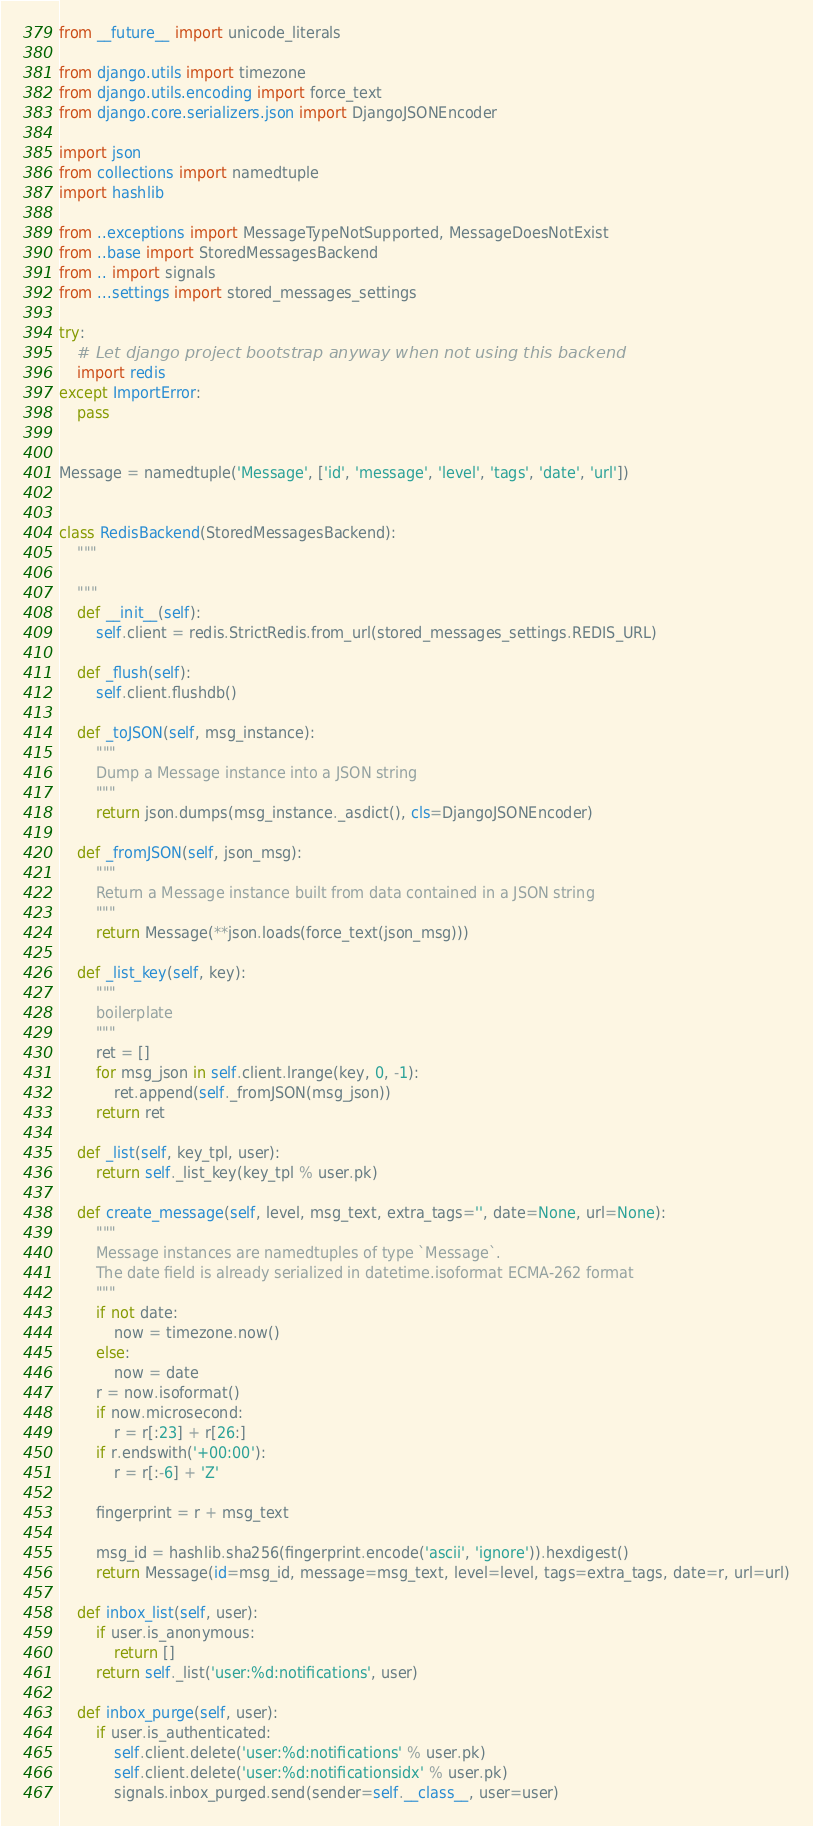<code> <loc_0><loc_0><loc_500><loc_500><_Python_>from __future__ import unicode_literals

from django.utils import timezone
from django.utils.encoding import force_text
from django.core.serializers.json import DjangoJSONEncoder

import json
from collections import namedtuple
import hashlib

from ..exceptions import MessageTypeNotSupported, MessageDoesNotExist
from ..base import StoredMessagesBackend
from .. import signals
from ...settings import stored_messages_settings

try:
    # Let django project bootstrap anyway when not using this backend
    import redis
except ImportError:
    pass


Message = namedtuple('Message', ['id', 'message', 'level', 'tags', 'date', 'url'])


class RedisBackend(StoredMessagesBackend):
    """

    """
    def __init__(self):
        self.client = redis.StrictRedis.from_url(stored_messages_settings.REDIS_URL)

    def _flush(self):
        self.client.flushdb()

    def _toJSON(self, msg_instance):
        """
        Dump a Message instance into a JSON string
        """
        return json.dumps(msg_instance._asdict(), cls=DjangoJSONEncoder)

    def _fromJSON(self, json_msg):
        """
        Return a Message instance built from data contained in a JSON string
        """
        return Message(**json.loads(force_text(json_msg)))

    def _list_key(self, key):
        """
        boilerplate
        """
        ret = []
        for msg_json in self.client.lrange(key, 0, -1):
            ret.append(self._fromJSON(msg_json))
        return ret

    def _list(self, key_tpl, user):
        return self._list_key(key_tpl % user.pk)

    def create_message(self, level, msg_text, extra_tags='', date=None, url=None):
        """
        Message instances are namedtuples of type `Message`.
        The date field is already serialized in datetime.isoformat ECMA-262 format
        """
        if not date:
            now = timezone.now()
        else:
            now = date
        r = now.isoformat()
        if now.microsecond:
            r = r[:23] + r[26:]
        if r.endswith('+00:00'):
            r = r[:-6] + 'Z'

        fingerprint = r + msg_text

        msg_id = hashlib.sha256(fingerprint.encode('ascii', 'ignore')).hexdigest()
        return Message(id=msg_id, message=msg_text, level=level, tags=extra_tags, date=r, url=url)

    def inbox_list(self, user):
        if user.is_anonymous:
            return []
        return self._list('user:%d:notifications', user)

    def inbox_purge(self, user):
        if user.is_authenticated:
            self.client.delete('user:%d:notifications' % user.pk)
            self.client.delete('user:%d:notificationsidx' % user.pk)
            signals.inbox_purged.send(sender=self.__class__, user=user)
</code> 